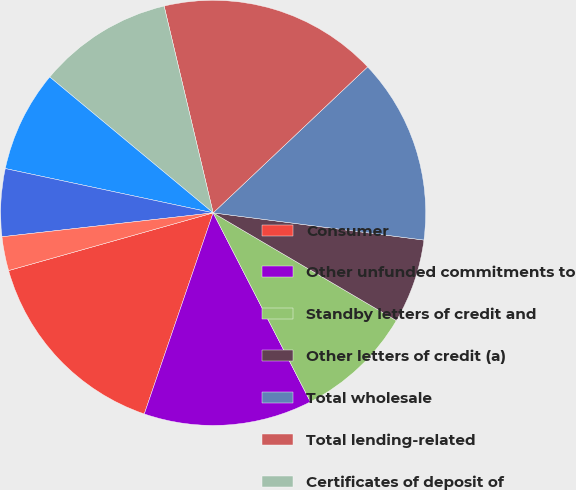Convert chart. <chart><loc_0><loc_0><loc_500><loc_500><pie_chart><fcel>Consumer<fcel>Other unfunded commitments to<fcel>Standby letters of credit and<fcel>Other letters of credit (a)<fcel>Total wholesale<fcel>Total lending-related<fcel>Certificates of deposit of<fcel>Long-term debt<fcel>FIN 46R long-term beneficial<fcel>Operating leases (d)<nl><fcel>15.38%<fcel>12.82%<fcel>8.98%<fcel>6.42%<fcel>14.1%<fcel>16.66%<fcel>10.26%<fcel>7.7%<fcel>5.14%<fcel>2.58%<nl></chart> 